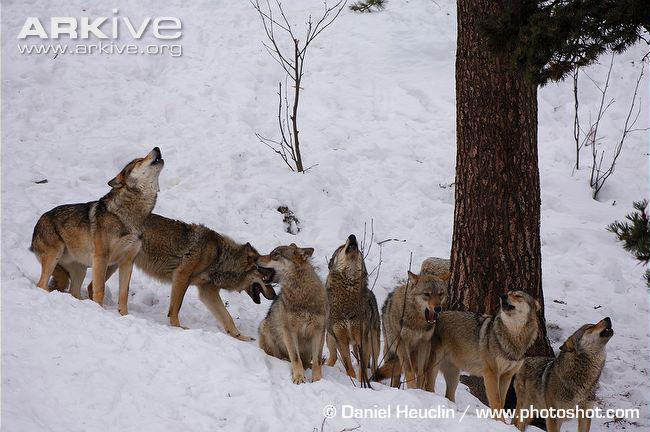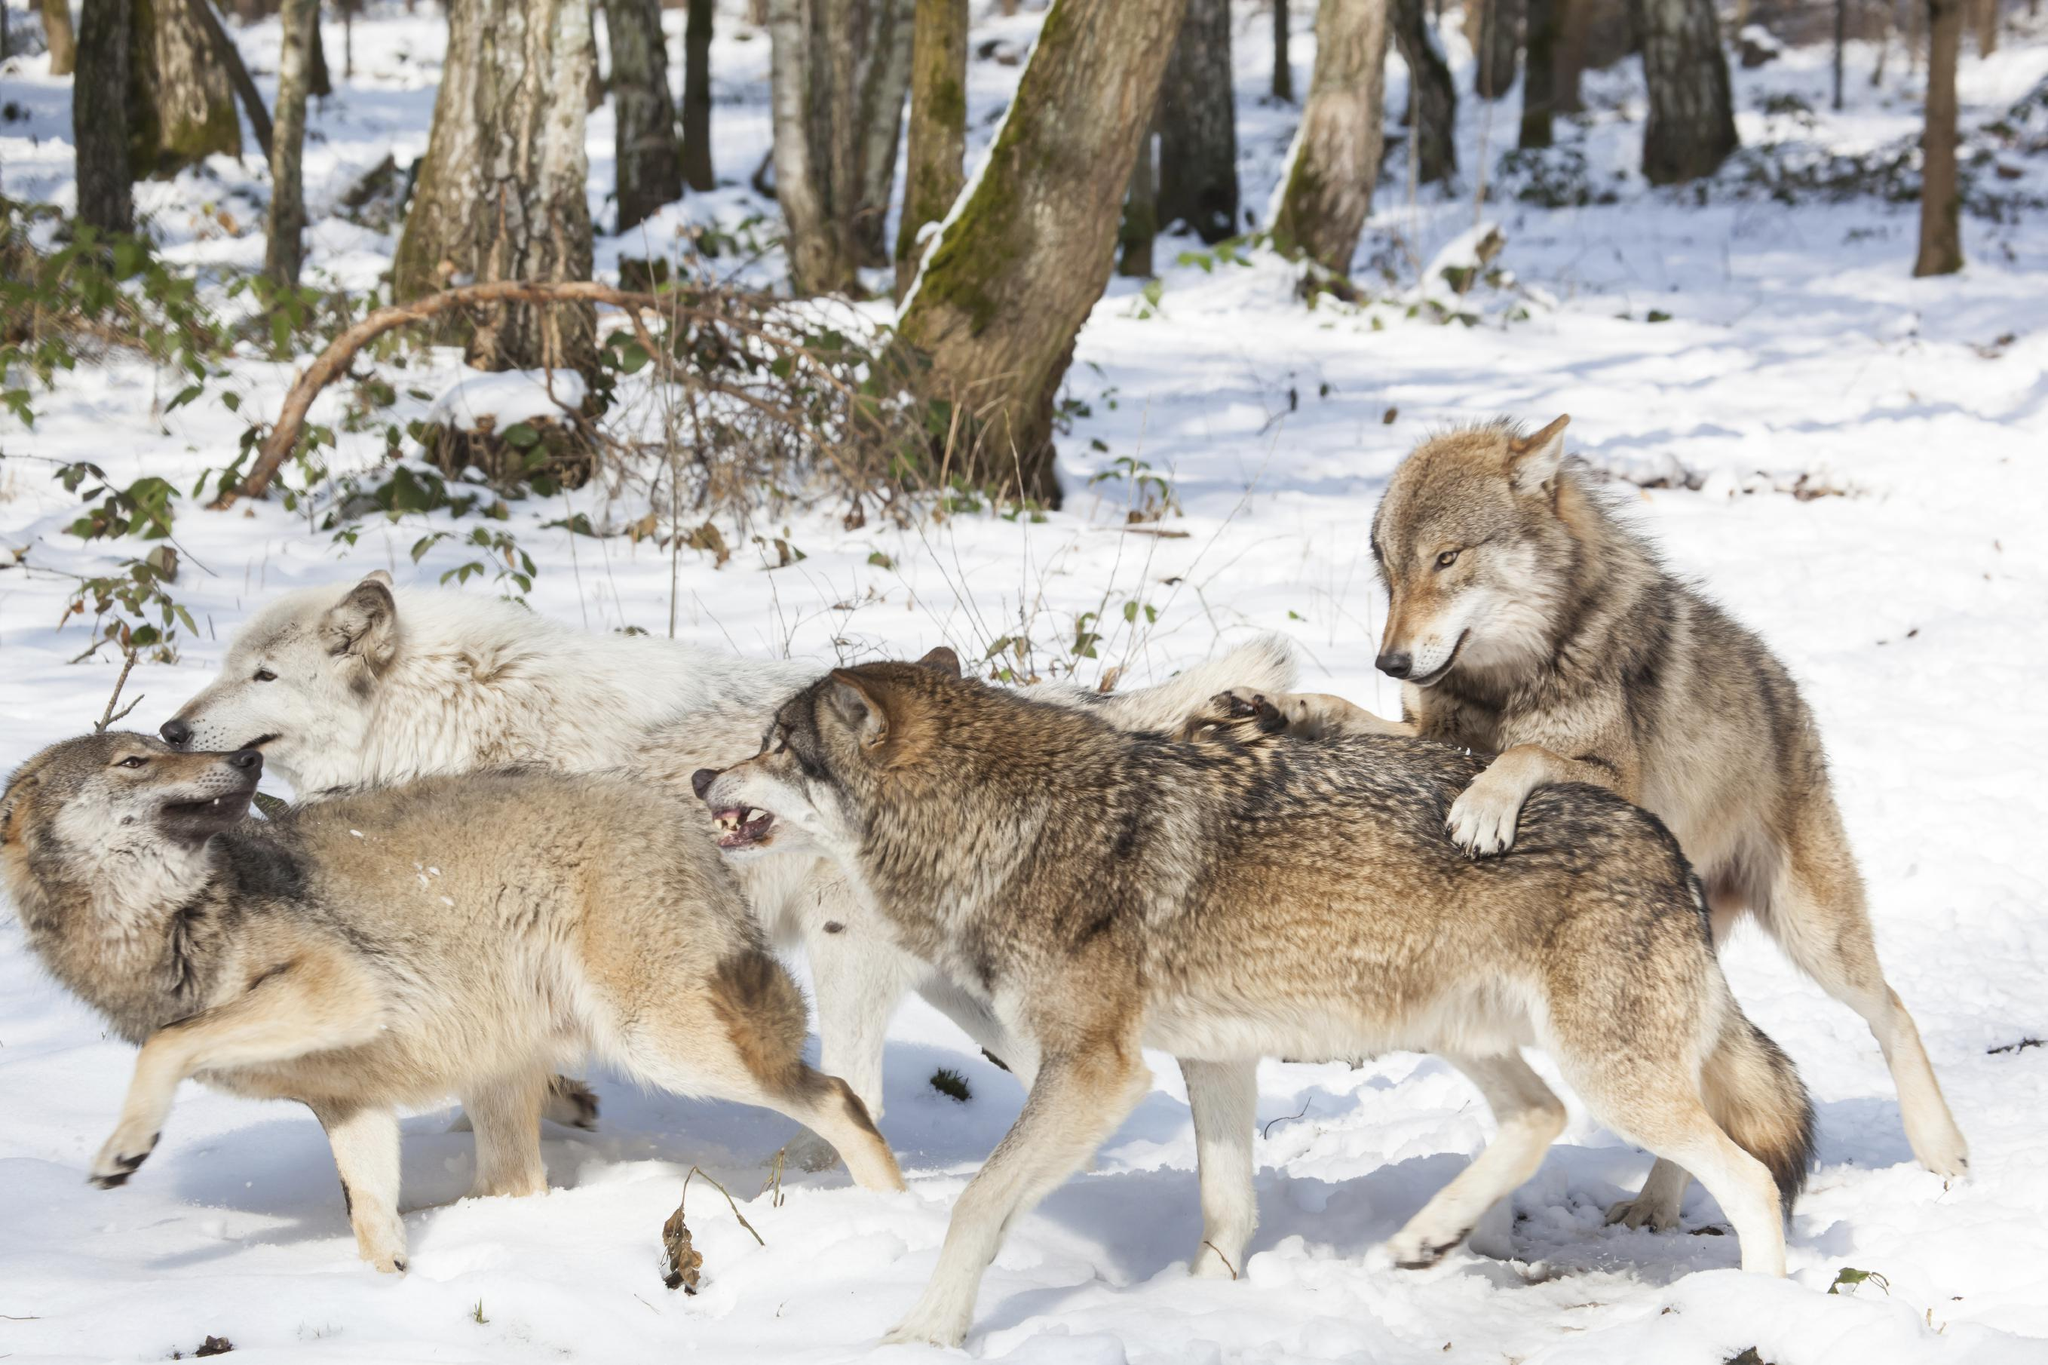The first image is the image on the left, the second image is the image on the right. For the images shown, is this caption "Some of the dogs are howling with their heads pointed up." true? Answer yes or no. Yes. The first image is the image on the left, the second image is the image on the right. For the images displayed, is the sentence "An image shows at least four wolves posed right by a large upright tree trunk." factually correct? Answer yes or no. Yes. 